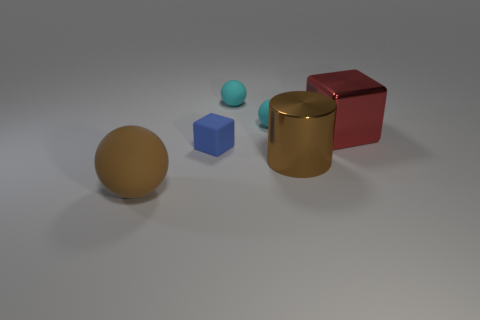Can you describe the objects and their spatial relationship? Certainly! In the image, there's a collection of geometric shapes all arranged on a flat surface. You can see a mustard-colored sphere closest to us. To the left, there's a smaller teal sphere. Moving rightward, there's a vivid blue cube, and further to the right, the red cube in question is next to a reflective gold cylinder. 
What can you infer about the lighting and texture of the objects? The lighting appears to be soft and diffused with slight shadows indicating an overhead light source. The objects have different textures; the gold cylinder is shiny, while the colored cubes seem to have a matte finish, and the spheres have a slight sheen, suggesting they might be slightly reflective. These subtle details give the image depth and dimensionality. 